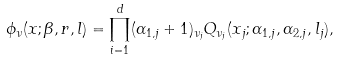Convert formula to latex. <formula><loc_0><loc_0><loc_500><loc_500>\phi _ { \nu } ( x ; \beta , r , l ) = \prod _ { i = 1 } ^ { d } ( \alpha _ { 1 , j } + 1 ) _ { \nu _ { j } } Q _ { \nu _ { j } } ( x _ { j } ; \alpha _ { 1 , j } , \alpha _ { 2 , j } , l _ { j } ) ,</formula> 